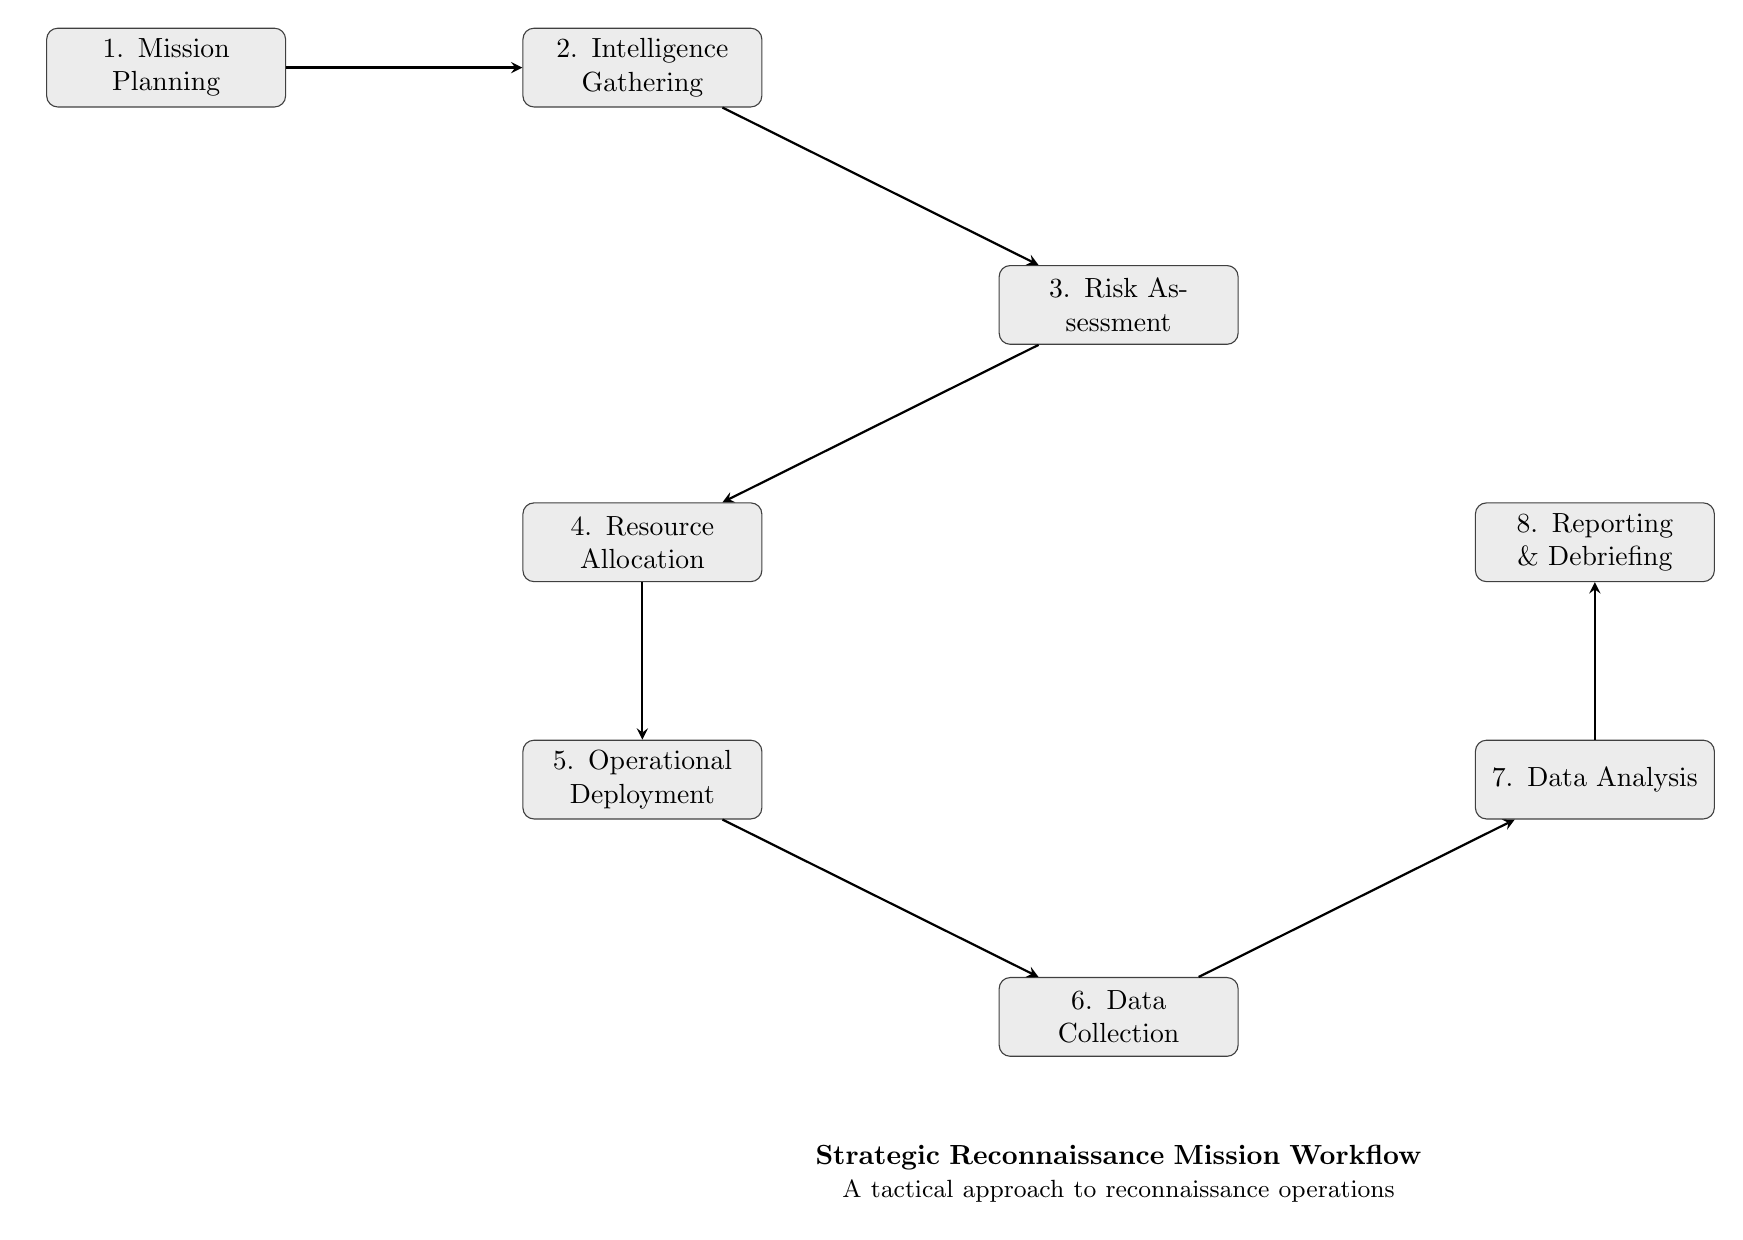What is the first step in the workflow? The diagram lists “Mission Planning” as the first node, indicating it is the initial step of the workflow.
Answer: Mission Planning How many total steps are present in the workflow? Looking at the diagram, we count eight nodes that represent the sequential actions of the workflow, confirming the total number of steps.
Answer: 8 What comes after Data Collection in the workflow? Following the arrow from the "Data Collection" node, we see it points to the "Data Analysis" node, identifying it as the next step.
Answer: Data Analysis Which node assesses potential threats? The "Risk Assessment" node is marked as the stage where evaluating potential threats takes place according to the flow's order.
Answer: Risk Assessment What is the last step of the workflow? The diagram indicates that “Reporting & Debriefing” is at the end of the sequence, as it has no outgoing arrow, marking it as the last action.
Answer: Reporting & Debriefing What connects Operational Deployment to Data Collection? An arrow is drawn from “Operational Deployment” to “Data Collection”, showing the progression from deploying units to the actual collection of data.
Answer: The arrow Which two nodes are directly connected after Resource Allocation? The next node after "Resource Allocation" is "Operational Deployment", and "Operational Deployment" does not lead to any other node before "Data Collection". This sequential connection indicates a direct link.
Answer: Operational Deployment and Data Collection What type of intelligence is gathered during the Intelligence Gathering stage? This stage includes various forms of information collection, including satellites, UAVs, and human intelligence as described in the "Intelligence Gathering" node.
Answer: Various types of intelligence What is the purpose of Risk Assessment? The diagram explicitly states that the Risk Assessment phase is designed to evaluate potential threats and operational risks.
Answer: To evaluate potential threats and operational risks 